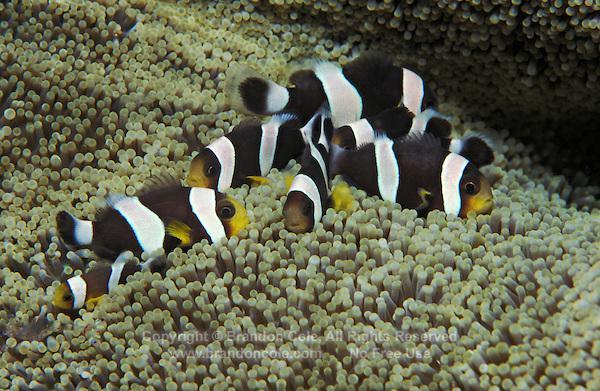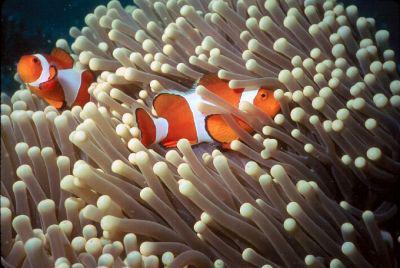The first image is the image on the left, the second image is the image on the right. For the images shown, is this caption "The left image contains at least one clown fish with white stripes." true? Answer yes or no. Yes. The first image is the image on the left, the second image is the image on the right. For the images shown, is this caption "In the right image, multiple clown fish with white stripes on bright orange are near flowing anemone tendrils with rounded tips." true? Answer yes or no. Yes. 